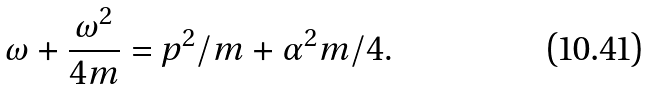Convert formula to latex. <formula><loc_0><loc_0><loc_500><loc_500>\omega + \frac { \omega ^ { 2 } } { 4 m } = p ^ { 2 } / m + \alpha ^ { 2 } m / 4 .</formula> 